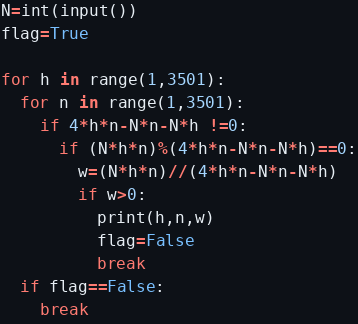Convert code to text. <code><loc_0><loc_0><loc_500><loc_500><_Python_>N=int(input())
flag=True

for h in range(1,3501):
  for n in range(1,3501):
    if 4*h*n-N*n-N*h !=0:
      if (N*h*n)%(4*h*n-N*n-N*h)==0:
        w=(N*h*n)//(4*h*n-N*n-N*h)
        if w>0:
          print(h,n,w)
          flag=False
          break
  if flag==False:
    break</code> 